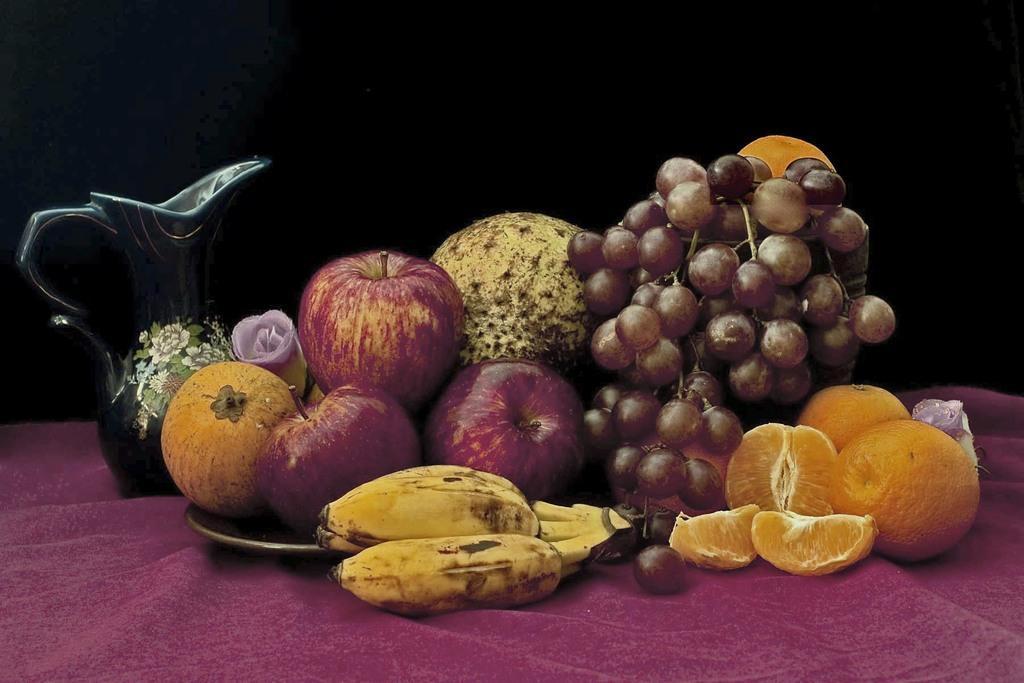In one or two sentences, can you explain what this image depicts? In this picture we can see some fruits, plate, mug are placed on the cloth. 